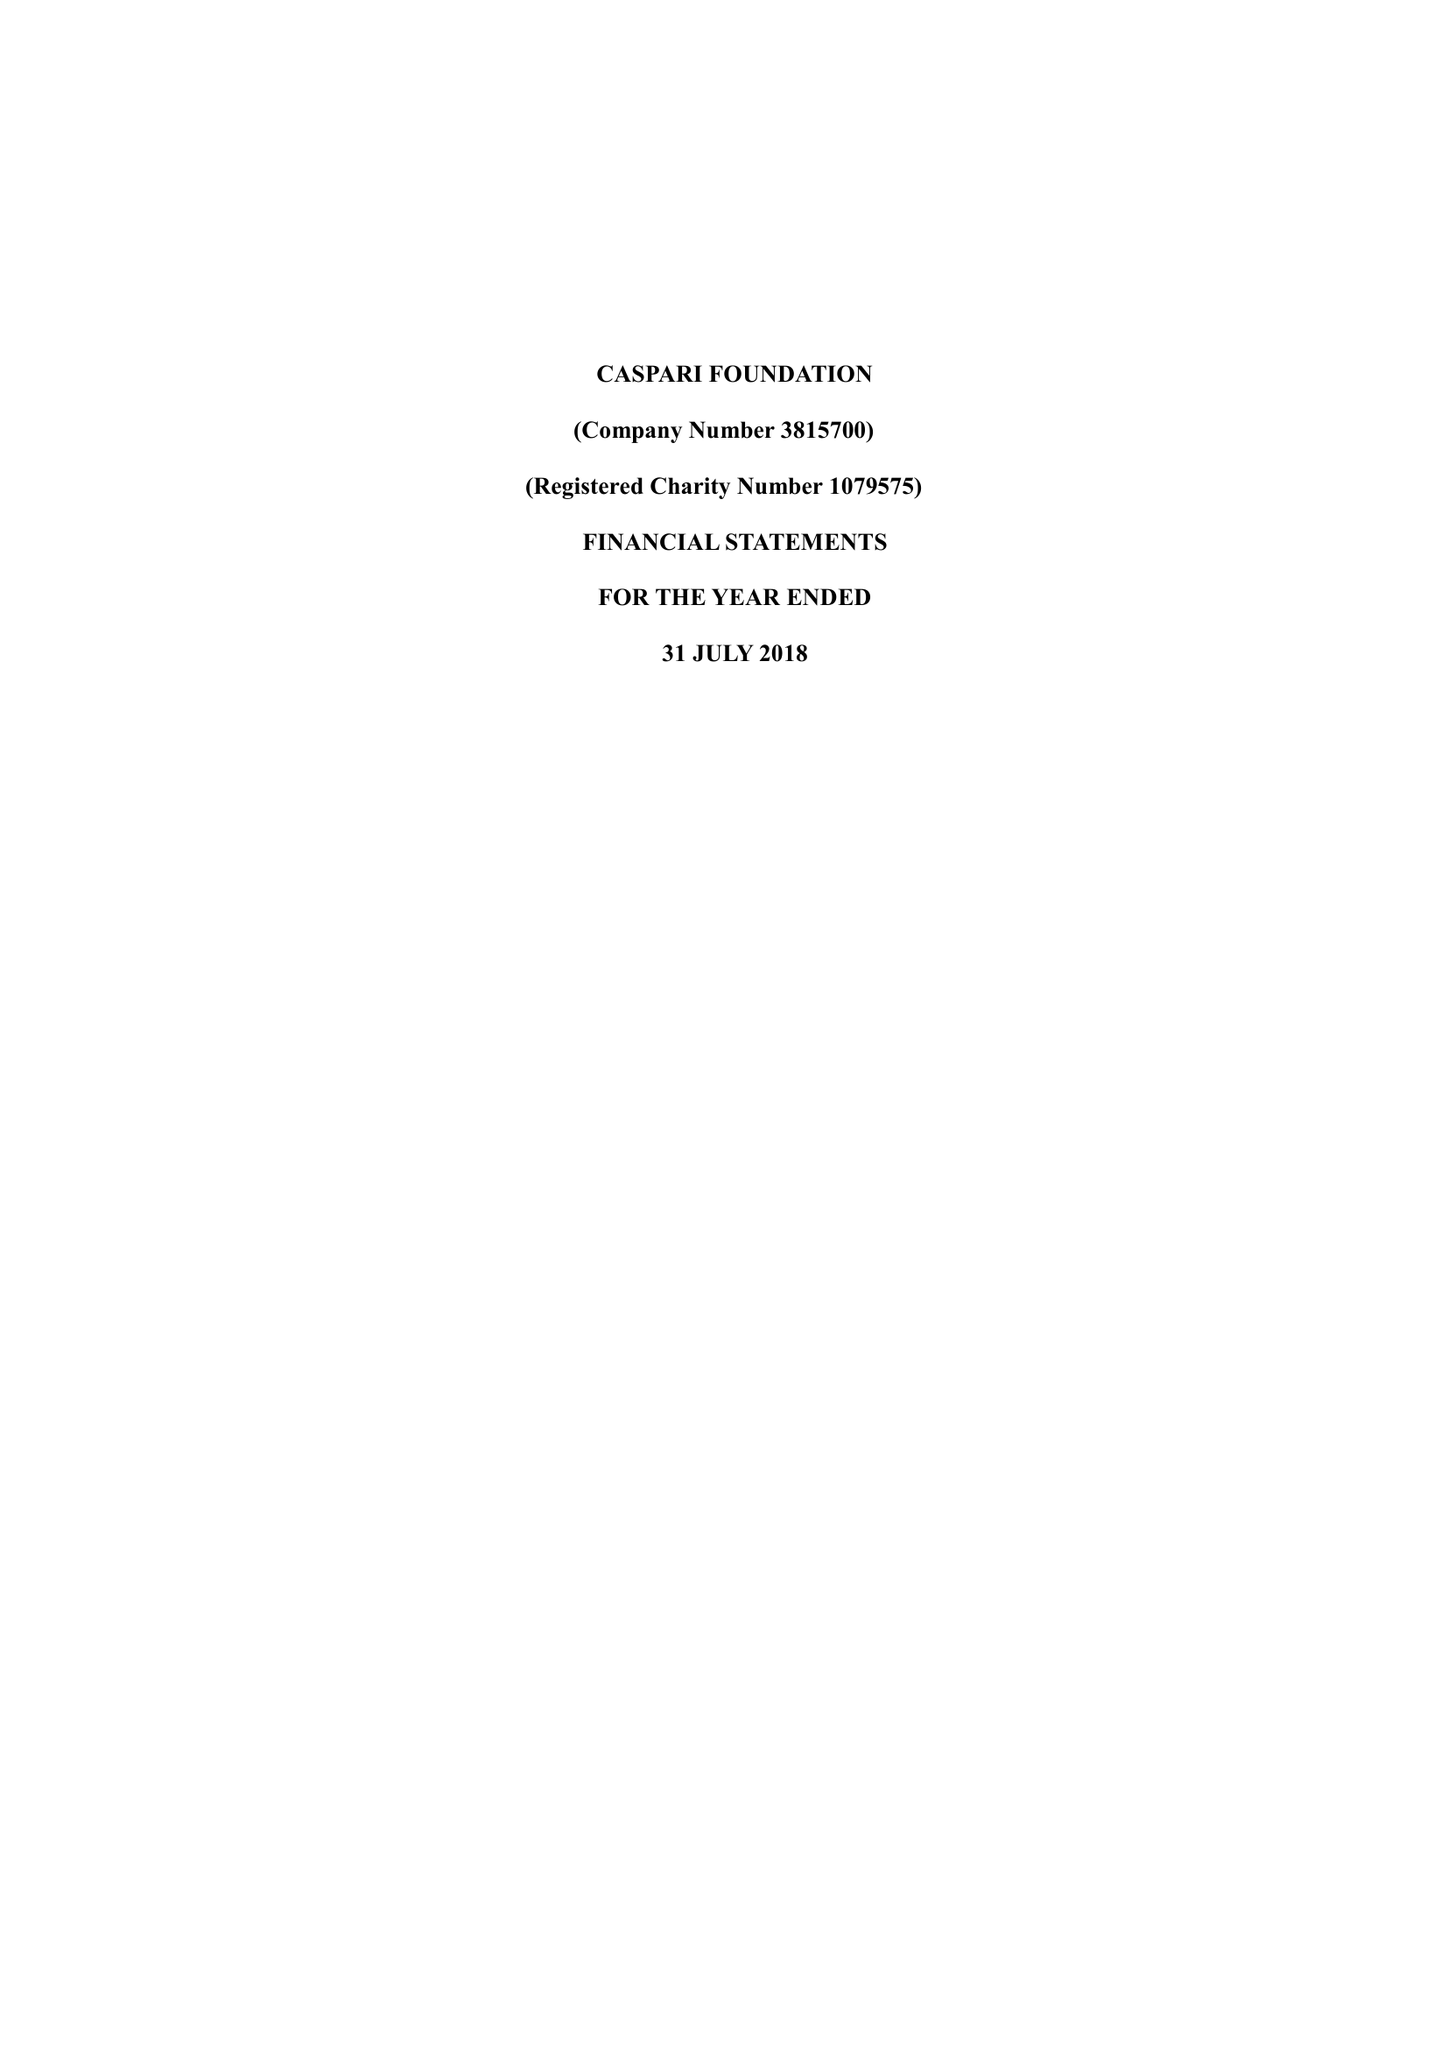What is the value for the address__street_line?
Answer the question using a single word or phrase. 225-229 SEVEN SISTERS ROAD 